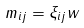Convert formula to latex. <formula><loc_0><loc_0><loc_500><loc_500>m _ { i j } = \xi _ { i j } w</formula> 